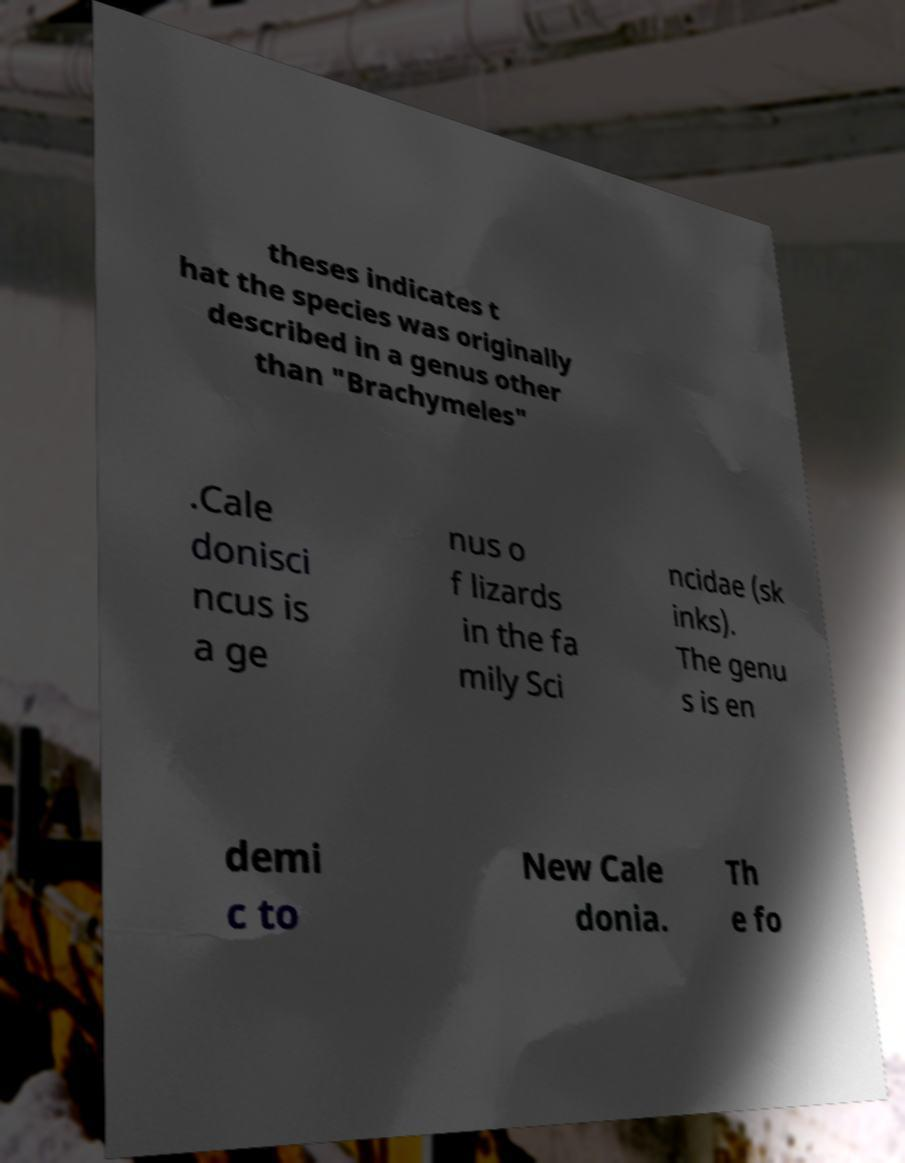I need the written content from this picture converted into text. Can you do that? theses indicates t hat the species was originally described in a genus other than "Brachymeles" .Cale donisci ncus is a ge nus o f lizards in the fa mily Sci ncidae (sk inks). The genu s is en demi c to New Cale donia. Th e fo 